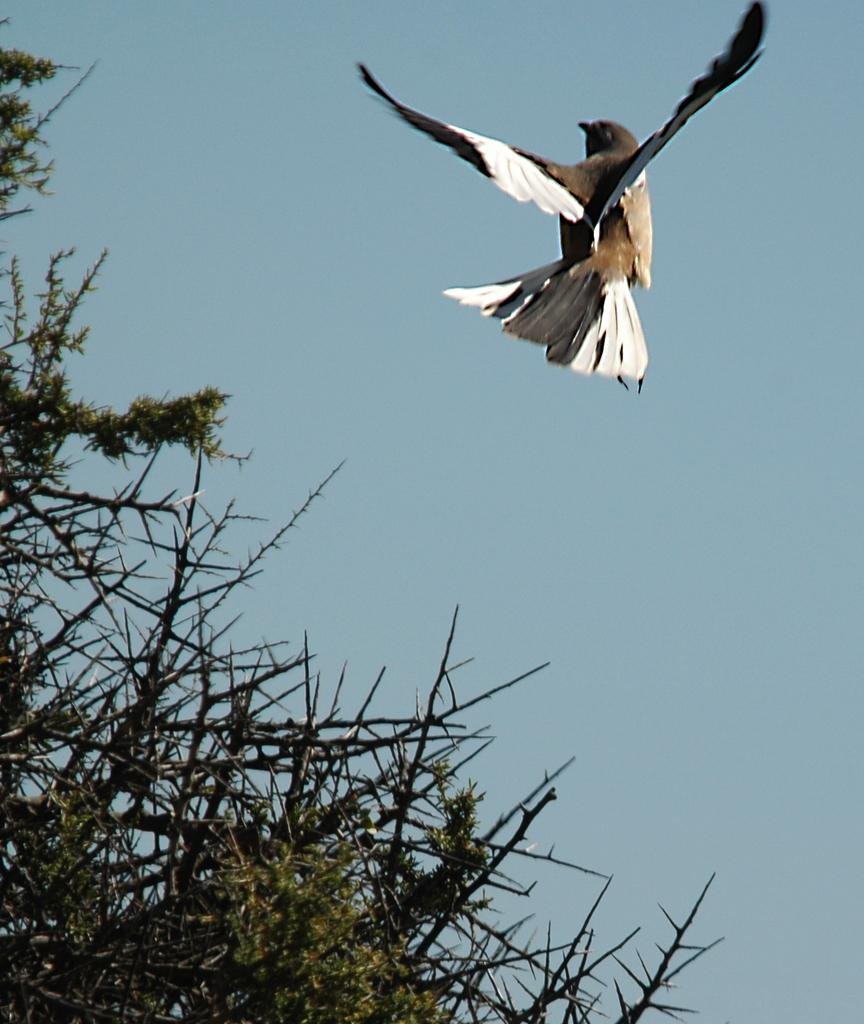What type of vegetation can be seen in the image? There are trees in the image. What is the bird in the image doing? A bird is flying in the air in the image. What can be seen in the background of the image? The sky is visible in the background of the image. Where are the chairs placed in the image? There are no chairs present in the image. What type of bait is the bird using to catch fish in the image? There is no bait or fish present in the image; the bird is simply flying in the air. 